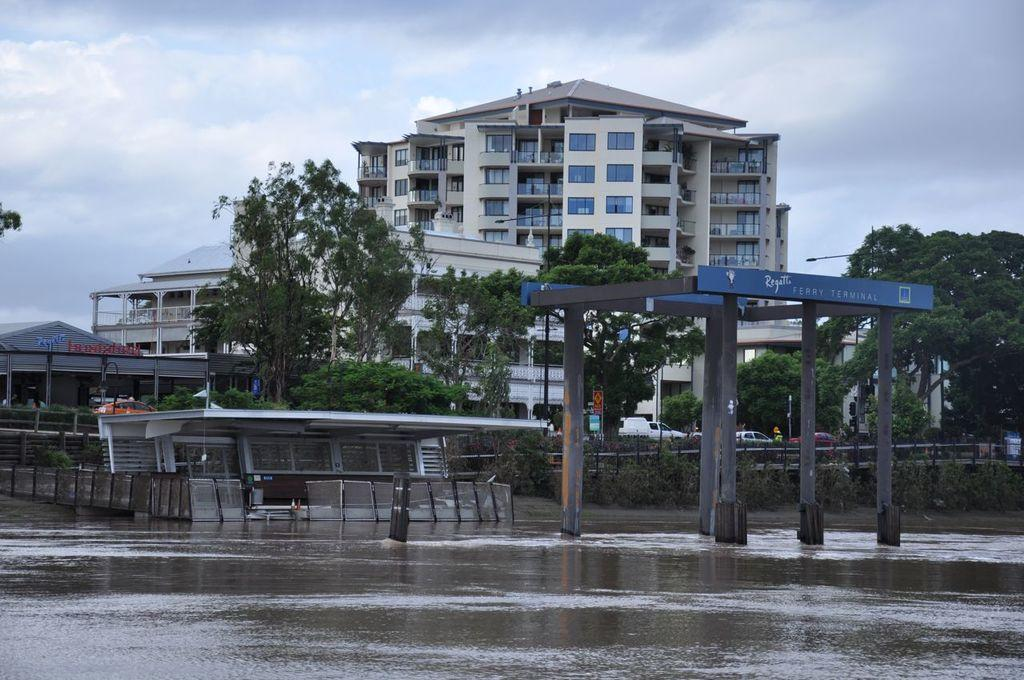What can be seen at the top of the image? The sky is visible in the image. What type of structure is present in the image? There is a building in the image. What type of vegetation is visible in front of the building? Trees are visible in front of the building. Where is the dock located in the image? There is no dock present in the image. What type of riddle can be solved by looking at the image? The image does not contain any riddles or puzzles to solve. 